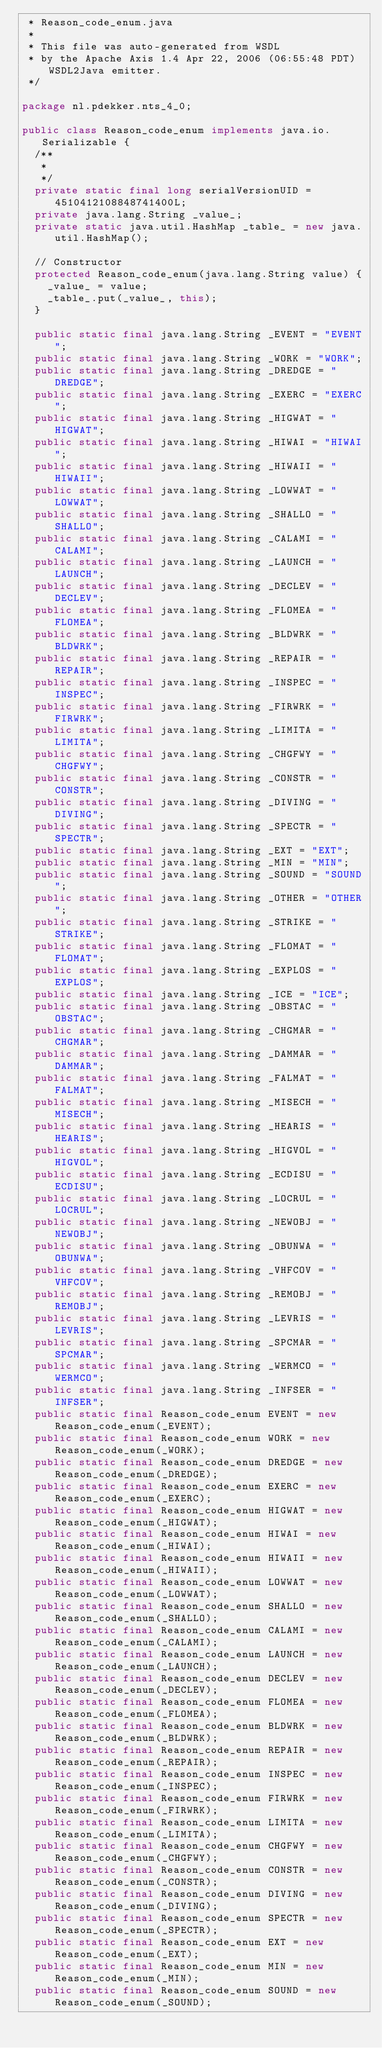Convert code to text. <code><loc_0><loc_0><loc_500><loc_500><_Java_> * Reason_code_enum.java
 *
 * This file was auto-generated from WSDL
 * by the Apache Axis 1.4 Apr 22, 2006 (06:55:48 PDT) WSDL2Java emitter.
 */

package nl.pdekker.nts_4_0;

public class Reason_code_enum implements java.io.Serializable {
	/**
	 * 
	 */
	private static final long serialVersionUID = 4510412108848741400L;
	private java.lang.String _value_;
	private static java.util.HashMap _table_ = new java.util.HashMap();

	// Constructor
	protected Reason_code_enum(java.lang.String value) {
		_value_ = value;
		_table_.put(_value_, this);
	}

	public static final java.lang.String _EVENT = "EVENT";
	public static final java.lang.String _WORK = "WORK";
	public static final java.lang.String _DREDGE = "DREDGE";
	public static final java.lang.String _EXERC = "EXERC";
	public static final java.lang.String _HIGWAT = "HIGWAT";
	public static final java.lang.String _HIWAI = "HIWAI";
	public static final java.lang.String _HIWAII = "HIWAII";
	public static final java.lang.String _LOWWAT = "LOWWAT";
	public static final java.lang.String _SHALLO = "SHALLO";
	public static final java.lang.String _CALAMI = "CALAMI";
	public static final java.lang.String _LAUNCH = "LAUNCH";
	public static final java.lang.String _DECLEV = "DECLEV";
	public static final java.lang.String _FLOMEA = "FLOMEA";
	public static final java.lang.String _BLDWRK = "BLDWRK";
	public static final java.lang.String _REPAIR = "REPAIR";
	public static final java.lang.String _INSPEC = "INSPEC";
	public static final java.lang.String _FIRWRK = "FIRWRK";
	public static final java.lang.String _LIMITA = "LIMITA";
	public static final java.lang.String _CHGFWY = "CHGFWY";
	public static final java.lang.String _CONSTR = "CONSTR";
	public static final java.lang.String _DIVING = "DIVING";
	public static final java.lang.String _SPECTR = "SPECTR";
	public static final java.lang.String _EXT = "EXT";
	public static final java.lang.String _MIN = "MIN";
	public static final java.lang.String _SOUND = "SOUND";
	public static final java.lang.String _OTHER = "OTHER";
	public static final java.lang.String _STRIKE = "STRIKE";
	public static final java.lang.String _FLOMAT = "FLOMAT";
	public static final java.lang.String _EXPLOS = "EXPLOS";
	public static final java.lang.String _ICE = "ICE";
	public static final java.lang.String _OBSTAC = "OBSTAC";
	public static final java.lang.String _CHGMAR = "CHGMAR";
	public static final java.lang.String _DAMMAR = "DAMMAR";
	public static final java.lang.String _FALMAT = "FALMAT";
	public static final java.lang.String _MISECH = "MISECH";
	public static final java.lang.String _HEARIS = "HEARIS";
	public static final java.lang.String _HIGVOL = "HIGVOL";
	public static final java.lang.String _ECDISU = "ECDISU";
	public static final java.lang.String _LOCRUL = "LOCRUL";
	public static final java.lang.String _NEWOBJ = "NEWOBJ";
	public static final java.lang.String _OBUNWA = "OBUNWA";
	public static final java.lang.String _VHFCOV = "VHFCOV";
	public static final java.lang.String _REMOBJ = "REMOBJ";
	public static final java.lang.String _LEVRIS = "LEVRIS";
	public static final java.lang.String _SPCMAR = "SPCMAR";
	public static final java.lang.String _WERMCO = "WERMCO";
	public static final java.lang.String _INFSER = "INFSER";
	public static final Reason_code_enum EVENT = new Reason_code_enum(_EVENT);
	public static final Reason_code_enum WORK = new Reason_code_enum(_WORK);
	public static final Reason_code_enum DREDGE = new Reason_code_enum(_DREDGE);
	public static final Reason_code_enum EXERC = new Reason_code_enum(_EXERC);
	public static final Reason_code_enum HIGWAT = new Reason_code_enum(_HIGWAT);
	public static final Reason_code_enum HIWAI = new Reason_code_enum(_HIWAI);
	public static final Reason_code_enum HIWAII = new Reason_code_enum(_HIWAII);
	public static final Reason_code_enum LOWWAT = new Reason_code_enum(_LOWWAT);
	public static final Reason_code_enum SHALLO = new Reason_code_enum(_SHALLO);
	public static final Reason_code_enum CALAMI = new Reason_code_enum(_CALAMI);
	public static final Reason_code_enum LAUNCH = new Reason_code_enum(_LAUNCH);
	public static final Reason_code_enum DECLEV = new Reason_code_enum(_DECLEV);
	public static final Reason_code_enum FLOMEA = new Reason_code_enum(_FLOMEA);
	public static final Reason_code_enum BLDWRK = new Reason_code_enum(_BLDWRK);
	public static final Reason_code_enum REPAIR = new Reason_code_enum(_REPAIR);
	public static final Reason_code_enum INSPEC = new Reason_code_enum(_INSPEC);
	public static final Reason_code_enum FIRWRK = new Reason_code_enum(_FIRWRK);
	public static final Reason_code_enum LIMITA = new Reason_code_enum(_LIMITA);
	public static final Reason_code_enum CHGFWY = new Reason_code_enum(_CHGFWY);
	public static final Reason_code_enum CONSTR = new Reason_code_enum(_CONSTR);
	public static final Reason_code_enum DIVING = new Reason_code_enum(_DIVING);
	public static final Reason_code_enum SPECTR = new Reason_code_enum(_SPECTR);
	public static final Reason_code_enum EXT = new Reason_code_enum(_EXT);
	public static final Reason_code_enum MIN = new Reason_code_enum(_MIN);
	public static final Reason_code_enum SOUND = new Reason_code_enum(_SOUND);</code> 